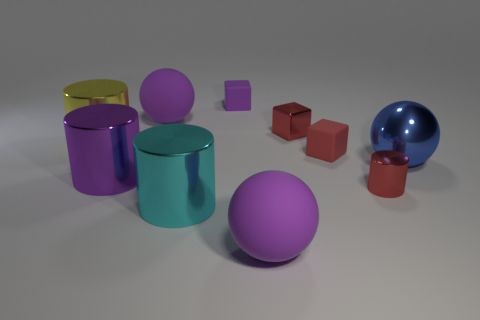Is the size of the cylinder that is in front of the tiny metal cylinder the same as the matte object that is in front of the tiny cylinder?
Your answer should be very brief. Yes. How many other objects are the same material as the big cyan object?
Ensure brevity in your answer.  5. Is the number of purple blocks on the left side of the big yellow metal thing greater than the number of red blocks on the left side of the small red metallic cylinder?
Make the answer very short. No. What is the purple sphere that is in front of the metallic sphere made of?
Offer a very short reply. Rubber. Do the large cyan metallic thing and the big blue shiny object have the same shape?
Provide a succinct answer. No. Is there anything else that has the same color as the big shiny sphere?
Provide a succinct answer. No. What color is the small thing that is the same shape as the large purple shiny thing?
Offer a very short reply. Red. Are there more red metal objects to the left of the large yellow cylinder than tiny objects?
Your response must be concise. No. The matte sphere in front of the metallic sphere is what color?
Provide a succinct answer. Purple. Do the blue object and the yellow cylinder have the same size?
Offer a very short reply. Yes. 